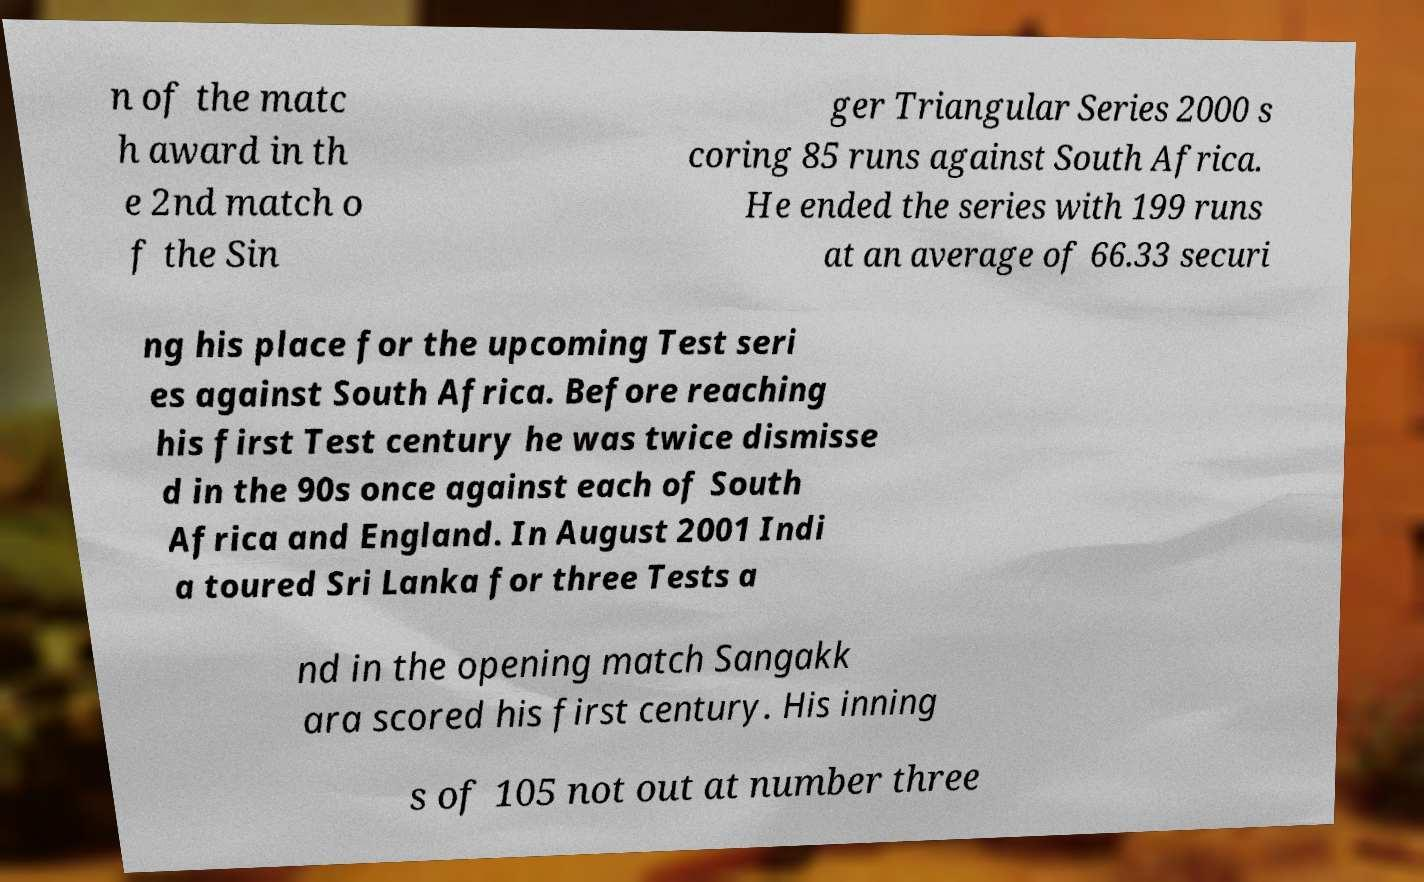I need the written content from this picture converted into text. Can you do that? n of the matc h award in th e 2nd match o f the Sin ger Triangular Series 2000 s coring 85 runs against South Africa. He ended the series with 199 runs at an average of 66.33 securi ng his place for the upcoming Test seri es against South Africa. Before reaching his first Test century he was twice dismisse d in the 90s once against each of South Africa and England. In August 2001 Indi a toured Sri Lanka for three Tests a nd in the opening match Sangakk ara scored his first century. His inning s of 105 not out at number three 